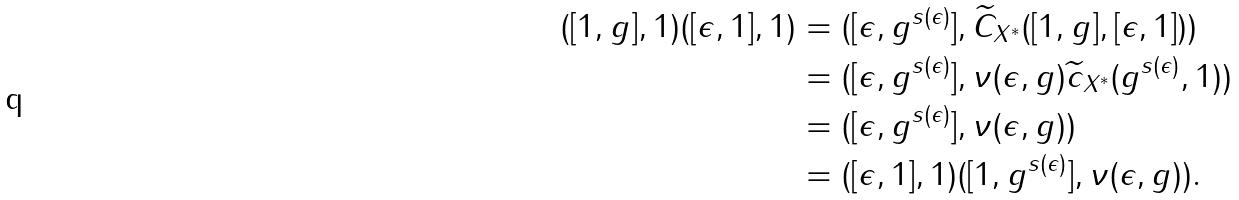Convert formula to latex. <formula><loc_0><loc_0><loc_500><loc_500>( [ 1 , g ] , 1 ) ( [ \epsilon , 1 ] , 1 ) & = ( [ \epsilon , g ^ { s ( \epsilon ) } ] , \widetilde { C } _ { X ^ { \ast } } ( [ 1 , g ] , [ \epsilon , 1 ] ) ) \\ & = ( [ \epsilon , g ^ { s ( \epsilon ) } ] , \nu ( \epsilon , g ) \widetilde { c } _ { X ^ { \ast } } ( g ^ { s ( \epsilon ) } , 1 ) ) \\ & = ( [ \epsilon , g ^ { s ( \epsilon ) } ] , \nu ( \epsilon , g ) ) \\ & = ( [ \epsilon , 1 ] , 1 ) ( [ 1 , g ^ { s ( \epsilon ) } ] , \nu ( \epsilon , g ) ) .</formula> 